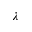<formula> <loc_0><loc_0><loc_500><loc_500>\lambda</formula> 